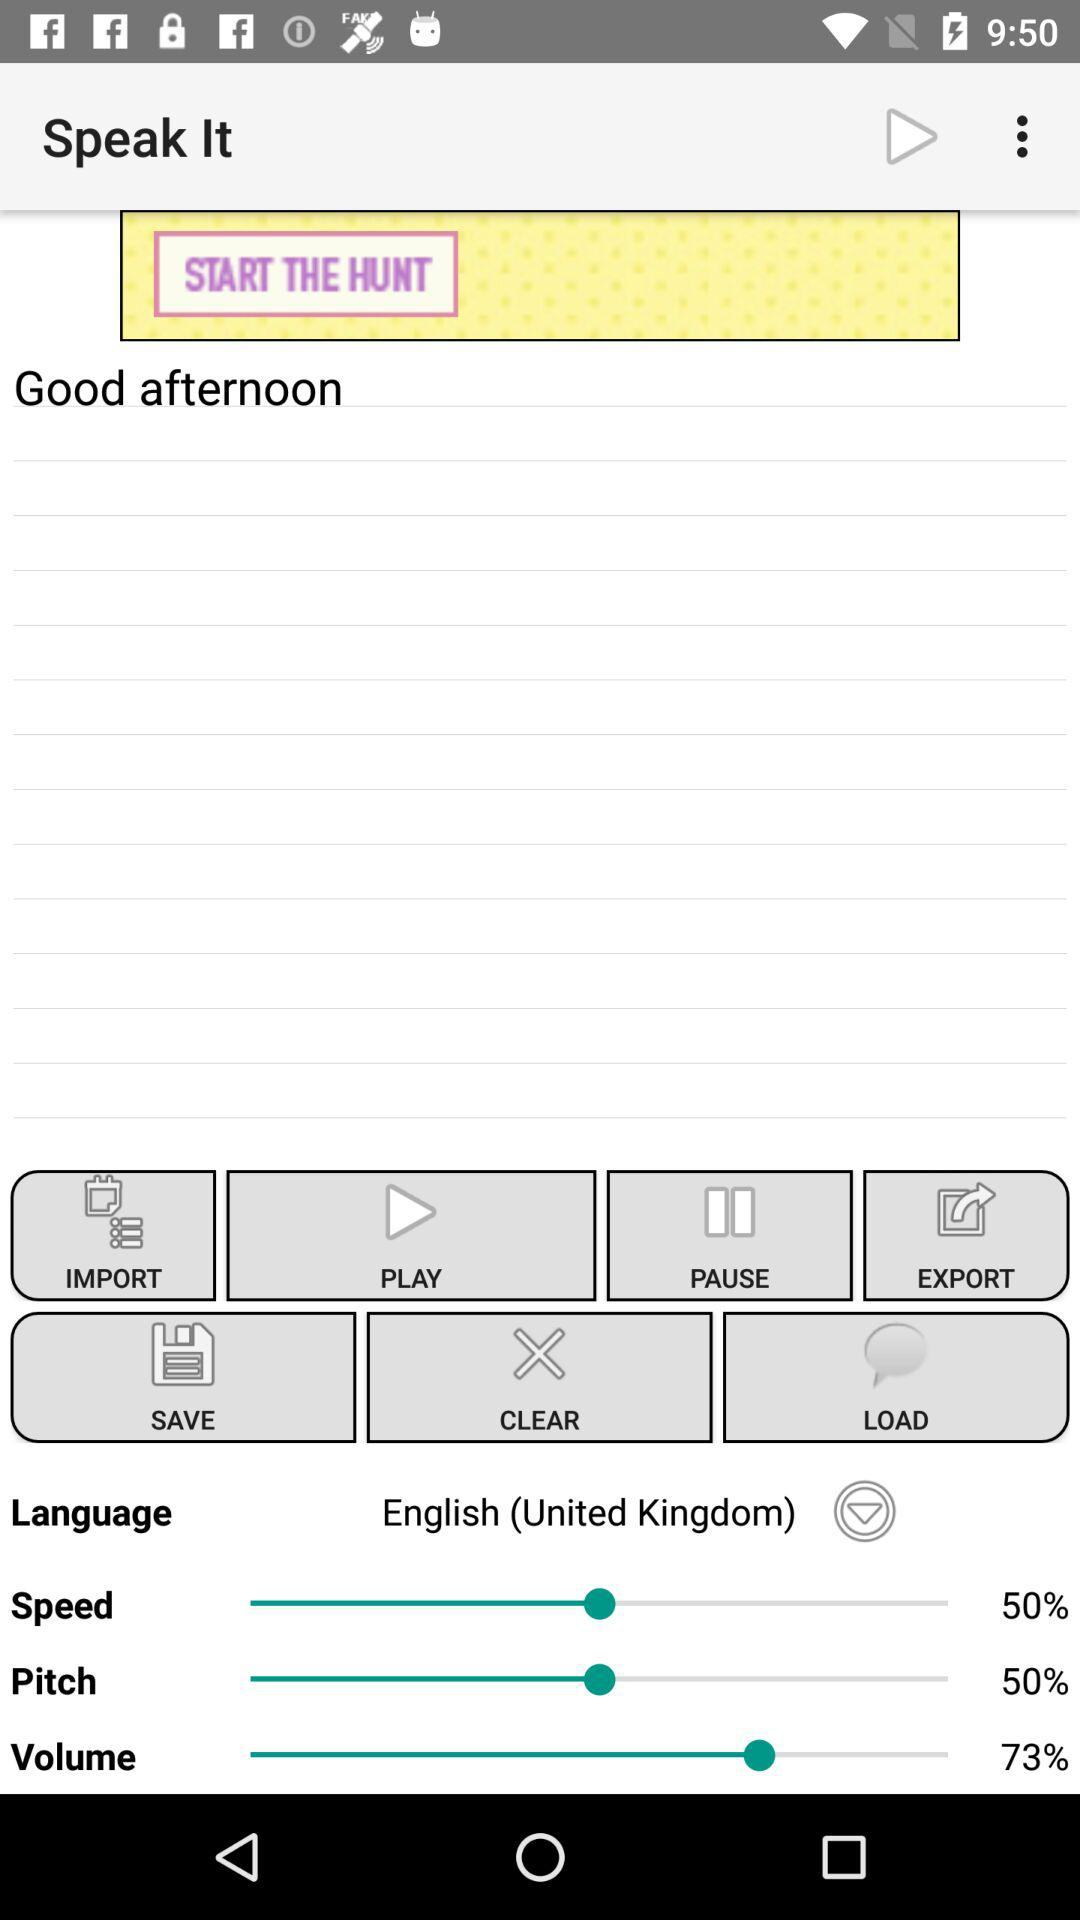What is the selected speed percentage? The selected speed percentage is 50. 